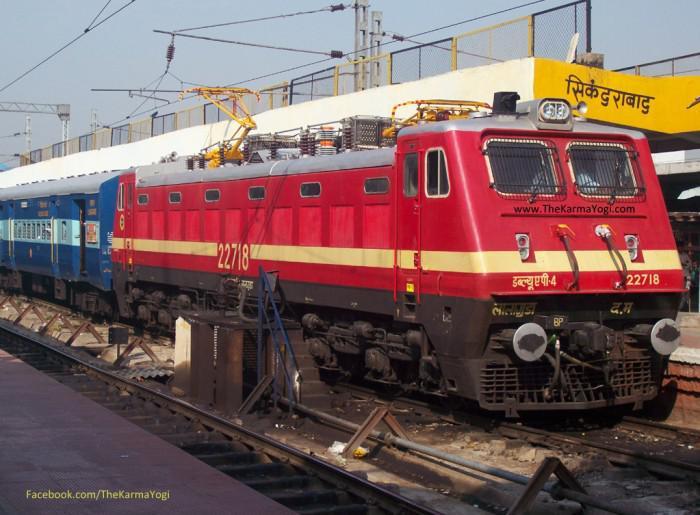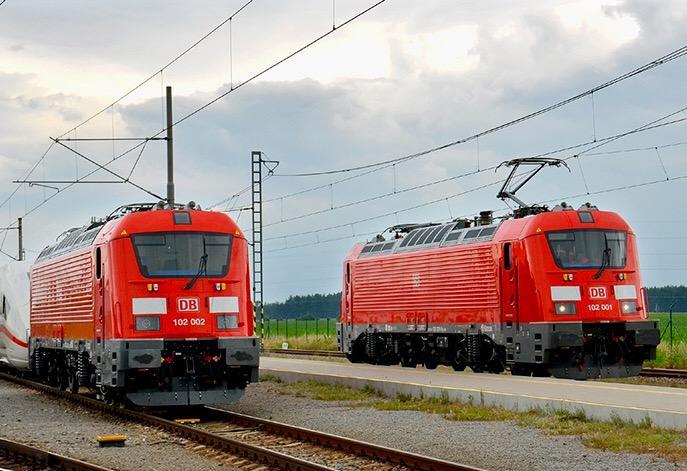The first image is the image on the left, the second image is the image on the right. Evaluate the accuracy of this statement regarding the images: "There are two trains in the image on the right.". Is it true? Answer yes or no. Yes. The first image is the image on the left, the second image is the image on the right. Examine the images to the left and right. Is the description "Exactly two trains in total are shown, with all trains pointing rightward." accurate? Answer yes or no. No. 